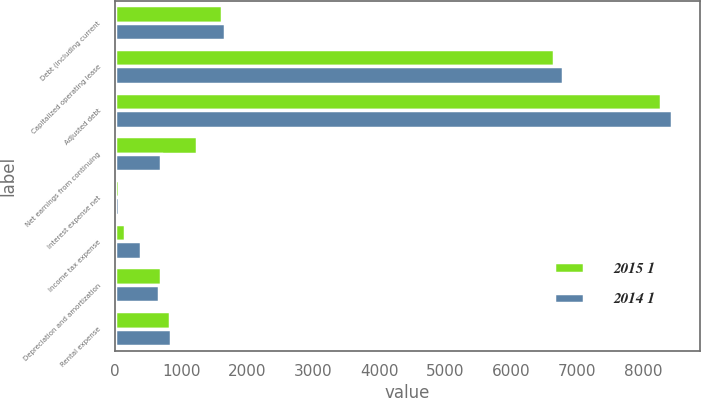Convert chart to OTSL. <chart><loc_0><loc_0><loc_500><loc_500><stacked_bar_chart><ecel><fcel>Debt (including current<fcel>Capitalized operating lease<fcel>Adjusted debt<fcel>Net earnings from continuing<fcel>Interest expense net<fcel>Income tax expense<fcel>Depreciation and amortization<fcel>Rental expense<nl><fcel>2015 1<fcel>1621<fcel>6653<fcel>8274<fcel>1246<fcel>63<fcel>141<fcel>689<fcel>832<nl><fcel>2014 1<fcel>1657<fcel>6781<fcel>8438<fcel>695<fcel>61<fcel>388<fcel>667<fcel>848<nl></chart> 